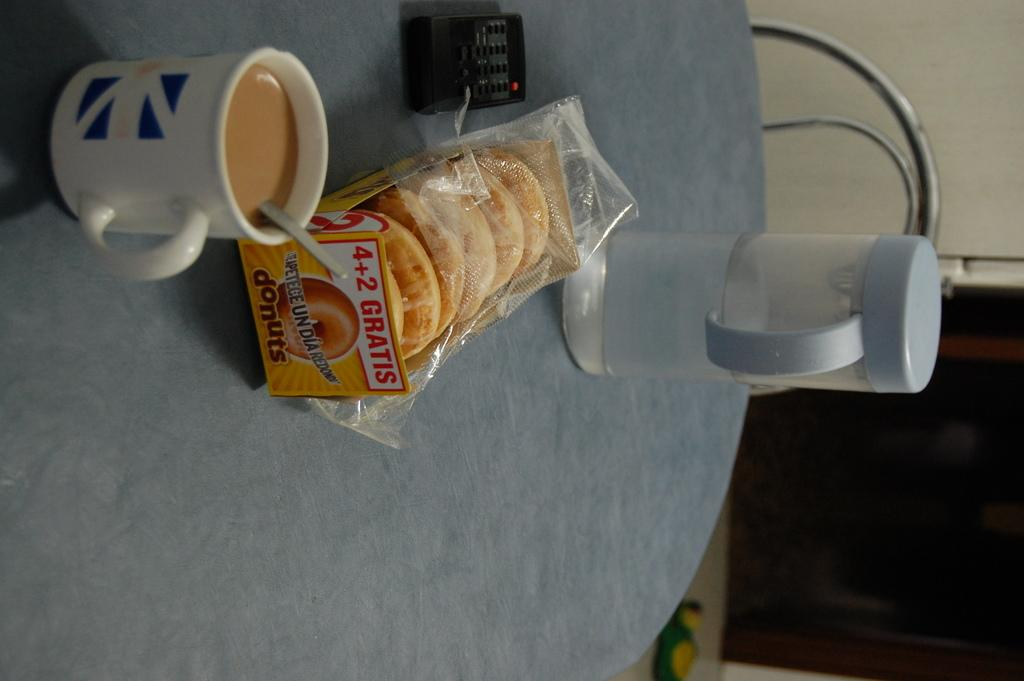<image>
Present a compact description of the photo's key features. A box of donuts claiming you get two free if you pay for four. 